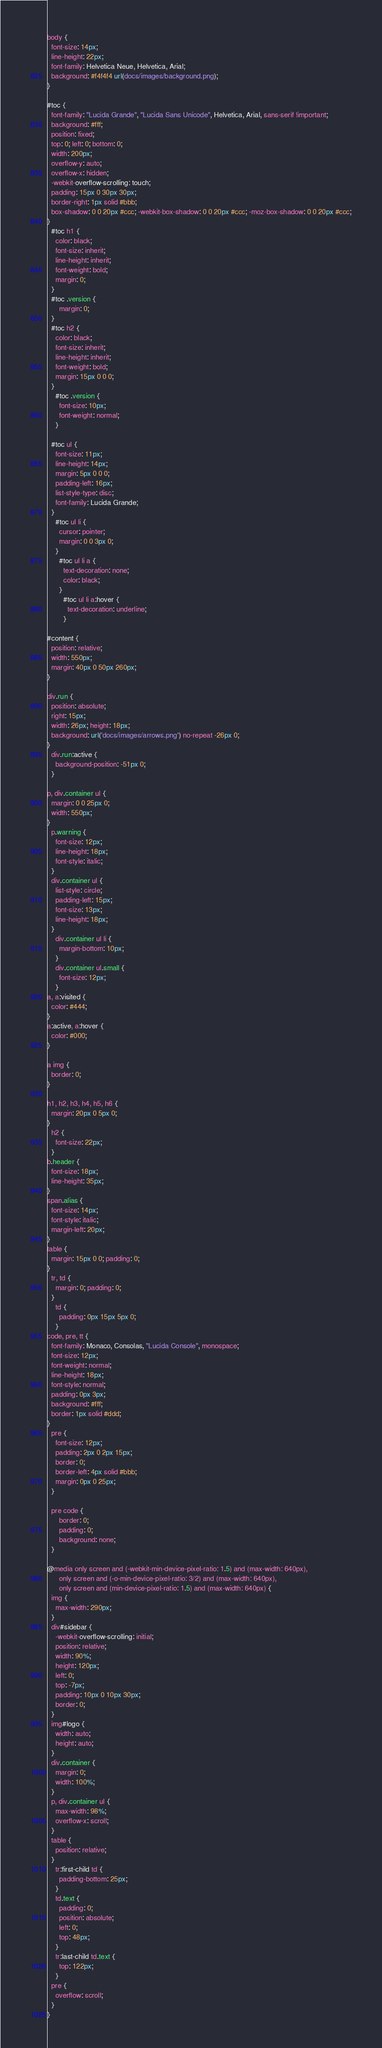Convert code to text. <code><loc_0><loc_0><loc_500><loc_500><_CSS_>
body {
  font-size: 14px;
  line-height: 22px;
  font-family: Helvetica Neue, Helvetica, Arial;
  background: #f4f4f4 url(docs/images/background.png);
}

#toc {
  font-family: "Lucida Grande", "Lucida Sans Unicode", Helvetica, Arial, sans-serif !important;
  background: #fff;
  position: fixed;
  top: 0; left: 0; bottom: 0;
  width: 200px;
  overflow-y: auto;
  overflow-x: hidden;
  -webkit-overflow-scrolling: touch;
  padding: 15px 0 30px 30px;
  border-right: 1px solid #bbb;
  box-shadow: 0 0 20px #ccc; -webkit-box-shadow: 0 0 20px #ccc; -moz-box-shadow: 0 0 20px #ccc;
}
  #toc h1 {
    color: black;
    font-size: inherit;
    line-height: inherit;
    font-weight: bold;
    margin: 0;
  }
  #toc .version {
      margin: 0;
  }
  #toc h2 {
    color: black;
    font-size: inherit;
    line-height: inherit;
    font-weight: bold;
    margin: 15px 0 0 0;
  }
    #toc .version {
      font-size: 10px;
      font-weight: normal;
    }

  #toc ul {
    font-size: 11px;
    line-height: 14px;
    margin: 5px 0 0 0;
    padding-left: 16px;
    list-style-type: disc;
    font-family: Lucida Grande;
  }
    #toc ul li {
      cursor: pointer;
      margin: 0 0 3px 0;
    }
      #toc ul li a {
        text-decoration: none;
        color: black;
      }
        #toc ul li a:hover {
          text-decoration: underline;
        }

#content {
  position: relative;
  width: 550px;
  margin: 40px 0 50px 260px;
}

div.run {
  position: absolute;
  right: 15px;
  width: 26px; height: 18px;
  background: url('docs/images/arrows.png') no-repeat -26px 0;
}
  div.run:active {
    background-position: -51px 0;
  }

p, div.container ul {
  margin: 0 0 25px 0;
  width: 550px;
}
  p.warning {
    font-size: 12px;
    line-height: 18px;
    font-style: italic;
  }
  div.container ul {
    list-style: circle;
    padding-left: 15px;
    font-size: 13px;
    line-height: 18px;
  }
    div.container ul li {
      margin-bottom: 10px;
    }
    div.container ul.small {
      font-size: 12px;
    }
a, a:visited {
  color: #444;
}
a:active, a:hover {
  color: #000;
}

a img {
  border: 0;
}

h1, h2, h3, h4, h5, h6 {
  margin: 20px 0 5px 0;
}
  h2 {
    font-size: 22px;
  }
b.header {
  font-size: 18px;
  line-height: 35px;
}
span.alias {
  font-size: 14px;
  font-style: italic;
  margin-left: 20px;
}
table {
  margin: 15px 0 0; padding: 0;
}
  tr, td {
    margin: 0; padding: 0;
  }
    td {
      padding: 0px 15px 5px 0;
    }
code, pre, tt {
  font-family: Monaco, Consolas, "Lucida Console", monospace;
  font-size: 12px;
  font-weight: normal;
  line-height: 18px;
  font-style: normal;
  padding: 0px 3px;
  background: #fff;
  border: 1px solid #ddd;
}
  pre {
    font-size: 12px;
    padding: 2px 0 2px 15px;
    border: 0;
    border-left: 4px solid #bbb;
    margin: 0px 0 25px;
  }

  pre code {
      border: 0;
      padding: 0;
      background: none;
  }

@media only screen and (-webkit-min-device-pixel-ratio: 1.5) and (max-width: 640px),
      only screen and (-o-min-device-pixel-ratio: 3/2) and (max-width: 640px),
      only screen and (min-device-pixel-ratio: 1.5) and (max-width: 640px) {
  img {
    max-width: 290px;
  }
  div#sidebar {
    -webkit-overflow-scrolling: initial;
    position: relative;
    width: 90%;
    height: 120px;
    left: 0;
    top: -7px;
    padding: 10px 0 10px 30px;
    border: 0;
  }
  img#logo {
    width: auto; 
    height: auto;
  }
  div.container {
    margin: 0;
    width: 100%;
  }
  p, div.container ul {
    max-width: 98%;
    overflow-x: scroll;
  }
  table {
    position: relative;
  }
    tr:first-child td {
      padding-bottom: 25px;
    }
    td.text {
      padding: 0;
      position: absolute;
      left: 0;
      top: 48px;
    }
    tr:last-child td.text {
      top: 122px;
    }
  pre {
    overflow: scroll;
  }
}
</code> 